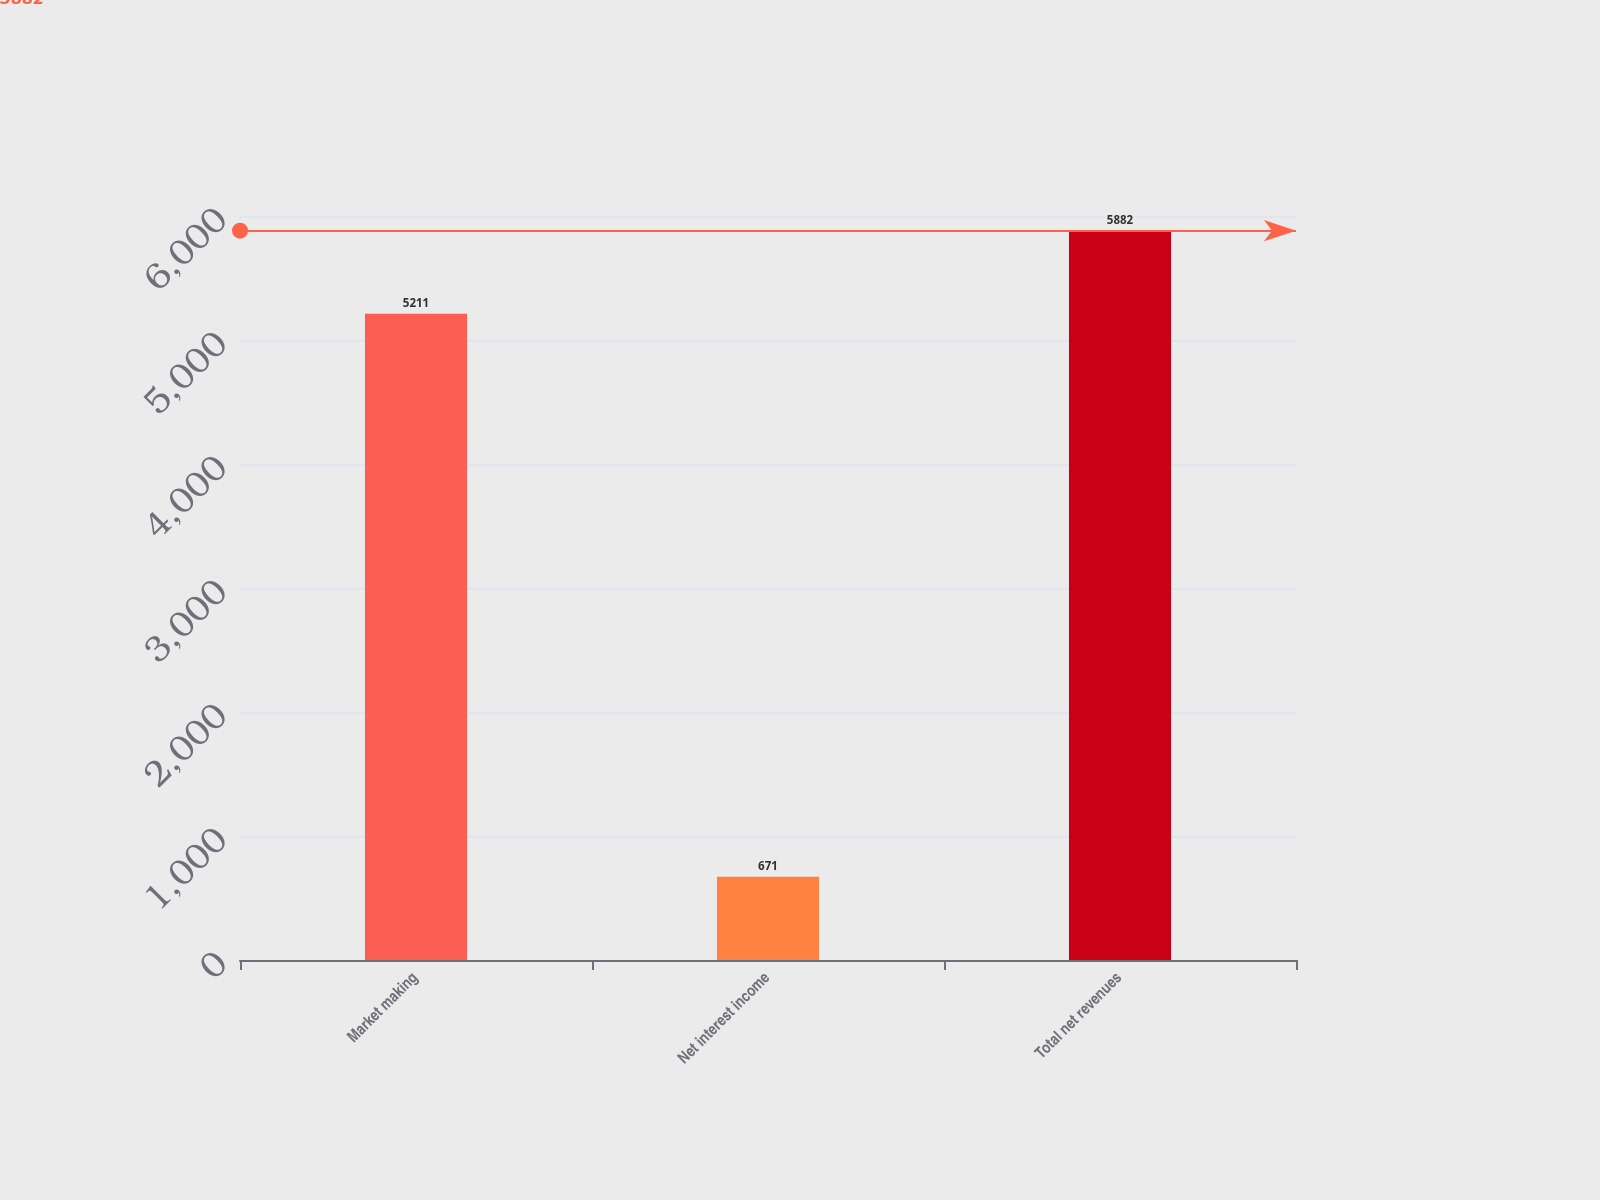Convert chart to OTSL. <chart><loc_0><loc_0><loc_500><loc_500><bar_chart><fcel>Market making<fcel>Net interest income<fcel>Total net revenues<nl><fcel>5211<fcel>671<fcel>5882<nl></chart> 